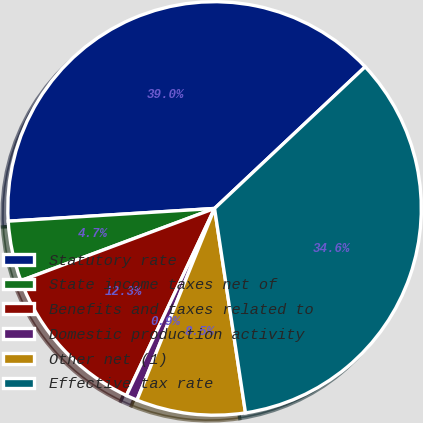Convert chart to OTSL. <chart><loc_0><loc_0><loc_500><loc_500><pie_chart><fcel>Statutory rate<fcel>State income taxes net of<fcel>Benefits and taxes related to<fcel>Domestic production activity<fcel>Other net (1)<fcel>Effective tax rate<nl><fcel>38.97%<fcel>4.7%<fcel>12.31%<fcel>0.89%<fcel>8.51%<fcel>34.62%<nl></chart> 